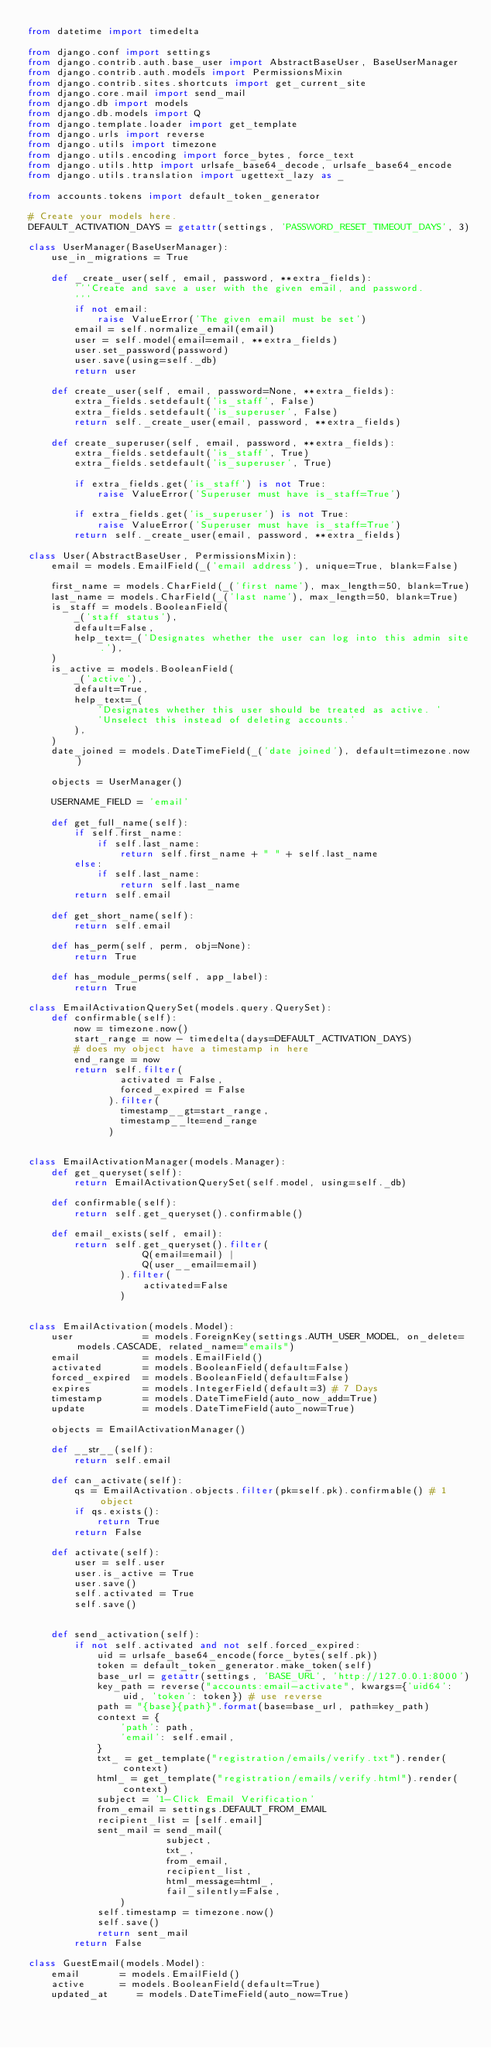Convert code to text. <code><loc_0><loc_0><loc_500><loc_500><_Python_>from datetime import timedelta

from django.conf import settings
from django.contrib.auth.base_user import AbstractBaseUser, BaseUserManager
from django.contrib.auth.models import PermissionsMixin
from django.contrib.sites.shortcuts import get_current_site
from django.core.mail import send_mail
from django.db import models
from django.db.models import Q
from django.template.loader import get_template
from django.urls import reverse
from django.utils import timezone
from django.utils.encoding import force_bytes, force_text
from django.utils.http import urlsafe_base64_decode, urlsafe_base64_encode
from django.utils.translation import ugettext_lazy as _

from accounts.tokens import default_token_generator

# Create your models here.
DEFAULT_ACTIVATION_DAYS = getattr(settings, 'PASSWORD_RESET_TIMEOUT_DAYS', 3)

class UserManager(BaseUserManager):
    use_in_migrations = True

    def _create_user(self, email, password, **extra_fields):
        '''Create and save a user with the given email, and password.
        '''
        if not email:
            raise ValueError('The given email must be set')
        email = self.normalize_email(email)
        user = self.model(email=email, **extra_fields)
        user.set_password(password)
        user.save(using=self._db)
        return user

    def create_user(self, email, password=None, **extra_fields):
        extra_fields.setdefault('is_staff', False)
        extra_fields.setdefault('is_superuser', False)
        return self._create_user(email, password, **extra_fields)

    def create_superuser(self, email, password, **extra_fields):
        extra_fields.setdefault('is_staff', True)
        extra_fields.setdefault('is_superuser', True)

        if extra_fields.get('is_staff') is not True:
            raise ValueError('Superuser must have is_staff=True')

        if extra_fields.get('is_superuser') is not True:
            raise ValueError('Superuser must have is_staff=True')
        return self._create_user(email, password, **extra_fields)

class User(AbstractBaseUser, PermissionsMixin):
    email = models.EmailField(_('email address'), unique=True, blank=False)

    first_name = models.CharField(_('first name'), max_length=50, blank=True)
    last_name = models.CharField(_('last name'), max_length=50, blank=True)
    is_staff = models.BooleanField(
        _('staff status'),
        default=False,
        help_text=_('Designates whether the user can log into this admin site.'),
    )
    is_active = models.BooleanField(
        _('active'),
        default=True,
        help_text=_(
            'Designates whether this user should be treated as active. '
            'Unselect this instead of deleting accounts.'
        ),
    )
    date_joined = models.DateTimeField(_('date joined'), default=timezone.now)

    objects = UserManager()

    USERNAME_FIELD = 'email'

    def get_full_name(self):
        if self.first_name:
            if self.last_name:
                return self.first_name + " " + self.last_name
        else:
            if self.last_name:
                return self.last_name
        return self.email

    def get_short_name(self):
        return self.email

    def has_perm(self, perm, obj=None):
        return True

    def has_module_perms(self, app_label):
        return True

class EmailActivationQuerySet(models.query.QuerySet):
    def confirmable(self):
        now = timezone.now()
        start_range = now - timedelta(days=DEFAULT_ACTIVATION_DAYS)
        # does my object have a timestamp in here
        end_range = now
        return self.filter(
                activated = False,
                forced_expired = False
              ).filter(
                timestamp__gt=start_range,
                timestamp__lte=end_range
              )


class EmailActivationManager(models.Manager):
    def get_queryset(self):
        return EmailActivationQuerySet(self.model, using=self._db)

    def confirmable(self):
        return self.get_queryset().confirmable()

    def email_exists(self, email):
        return self.get_queryset().filter(
                    Q(email=email) | 
                    Q(user__email=email)
                ).filter(
                    activated=False
                )


class EmailActivation(models.Model):
    user            = models.ForeignKey(settings.AUTH_USER_MODEL, on_delete=models.CASCADE, related_name="emails")
    email           = models.EmailField()
    activated       = models.BooleanField(default=False)
    forced_expired  = models.BooleanField(default=False)
    expires         = models.IntegerField(default=3) # 7 Days
    timestamp       = models.DateTimeField(auto_now_add=True)
    update          = models.DateTimeField(auto_now=True)

    objects = EmailActivationManager()

    def __str__(self):
        return self.email

    def can_activate(self):
        qs = EmailActivation.objects.filter(pk=self.pk).confirmable() # 1 object
        if qs.exists():
            return True
        return False

    def activate(self):
        user = self.user
        user.is_active = True
        user.save()
        self.activated = True
        self.save()


    def send_activation(self):
        if not self.activated and not self.forced_expired:
            uid = urlsafe_base64_encode(force_bytes(self.pk))
            token = default_token_generator.make_token(self)
            base_url = getattr(settings, 'BASE_URL', 'http://127.0.0.1:8000')
            key_path = reverse("accounts:email-activate", kwargs={'uid64': uid, 'token': token}) # use reverse
            path = "{base}{path}".format(base=base_url, path=key_path)
            context = {
                'path': path,
                'email': self.email,
            }
            txt_ = get_template("registration/emails/verify.txt").render(context)
            html_ = get_template("registration/emails/verify.html").render(context)
            subject = '1-Click Email Verification'
            from_email = settings.DEFAULT_FROM_EMAIL
            recipient_list = [self.email]
            sent_mail = send_mail(
                        subject,
                        txt_,
                        from_email,
                        recipient_list,
                        html_message=html_,
                        fail_silently=False,
                )
            self.timestamp = timezone.now()
            self.save()
            return sent_mail
        return False

class GuestEmail(models.Model):
    email       = models.EmailField()
    active      = models.BooleanField(default=True)
    updated_at     = models.DateTimeField(auto_now=True)</code> 